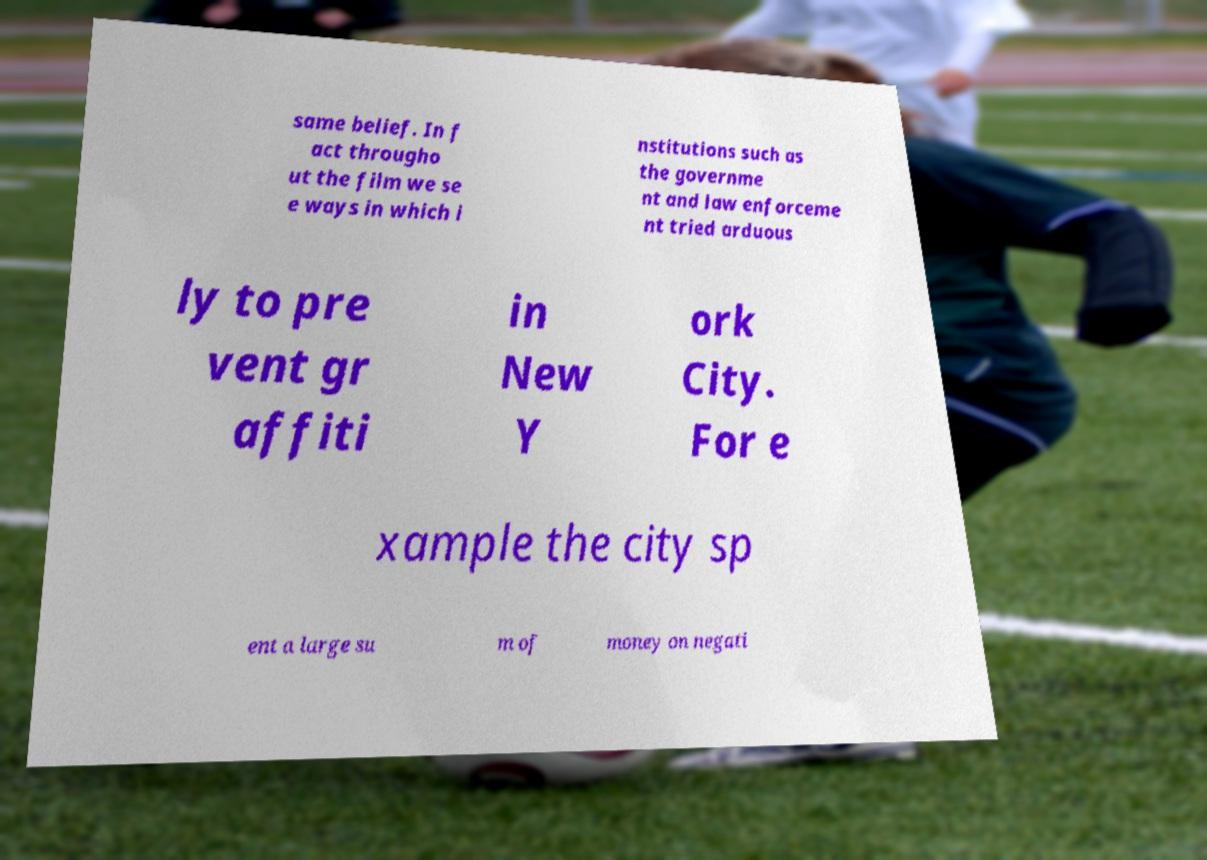Could you extract and type out the text from this image? same belief. In f act througho ut the film we se e ways in which i nstitutions such as the governme nt and law enforceme nt tried arduous ly to pre vent gr affiti in New Y ork City. For e xample the city sp ent a large su m of money on negati 